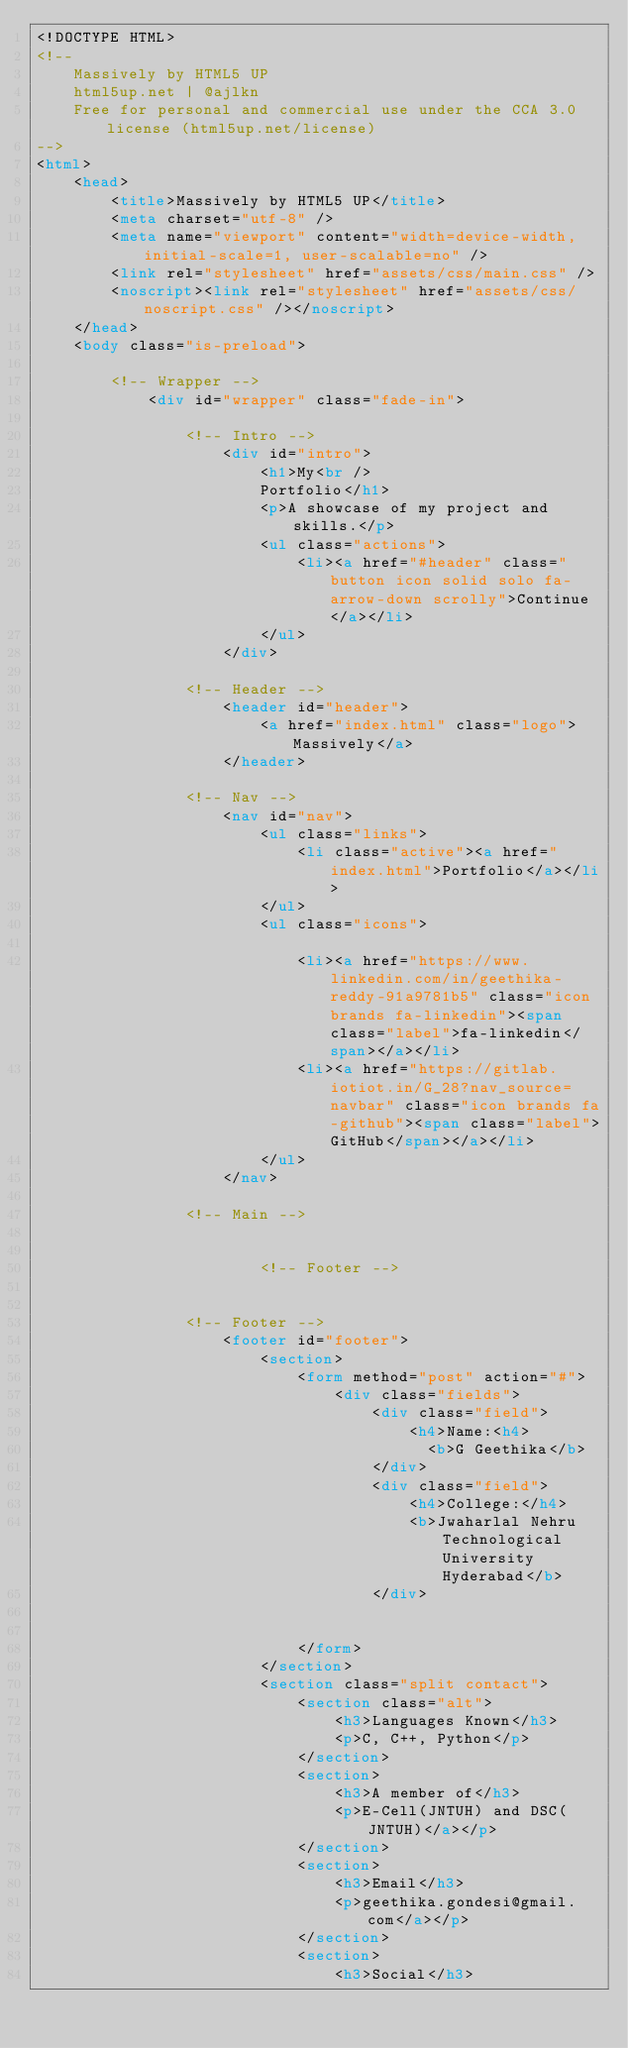Convert code to text. <code><loc_0><loc_0><loc_500><loc_500><_HTML_><!DOCTYPE HTML>
<!--
	Massively by HTML5 UP
	html5up.net | @ajlkn
	Free for personal and commercial use under the CCA 3.0 license (html5up.net/license)
-->
<html>
	<head>
		<title>Massively by HTML5 UP</title>
		<meta charset="utf-8" />
		<meta name="viewport" content="width=device-width, initial-scale=1, user-scalable=no" />
		<link rel="stylesheet" href="assets/css/main.css" />
		<noscript><link rel="stylesheet" href="assets/css/noscript.css" /></noscript>
	</head>
	<body class="is-preload">

		<!-- Wrapper -->
			<div id="wrapper" class="fade-in">

				<!-- Intro -->
					<div id="intro">
						<h1>My<br />
						Portfolio</h1>
						<p>A showcase of my project and skills.</p>
						<ul class="actions">
							<li><a href="#header" class="button icon solid solo fa-arrow-down scrolly">Continue</a></li>
						</ul>
					</div>

				<!-- Header -->
					<header id="header">
						<a href="index.html" class="logo">Massively</a>
					</header>

				<!-- Nav -->
					<nav id="nav">
						<ul class="links">
							<li class="active"><a href="index.html">Portfolio</a></li>
						</ul>
						<ul class="icons">
							
							<li><a href="https://www.linkedin.com/in/geethika-reddy-91a9781b5" class="icon brands fa-linkedin"><span class="label">fa-linkedin</span></a></li>
							<li><a href="https://gitlab.iotiot.in/G_28?nav_source=navbar" class="icon brands fa-github"><span class="label">GitHub</span></a></li>
						</ul>
					</nav>

				<!-- Main -->
					
						
						<!-- Footer -->
							

				<!-- Footer -->
					<footer id="footer">
						<section>
							<form method="post" action="#">
								<div class="fields">
									<div class="field">
										<h4>Name:<h4>
						                  <b>G Geethika</b>
									</div>
									<div class="field">
										<h4>College:</h4>
										<b>Jwaharlal Nehru Technological University Hyderabad</b>
									</div>
									
								
							</form>
						</section>
						<section class="split contact">
							<section class="alt">
								<h3>Languages Known</h3>
								<p>C, C++, Python</p>
							</section>
							<section>
								<h3>A member of</h3>
								<p>E-Cell(JNTUH) and DSC(JNTUH)</a></p>
							</section>
							<section>
								<h3>Email</h3>
								<p>geethika.gondesi@gmail.com</a></p>
							</section>
							<section>
								<h3>Social</h3></code> 